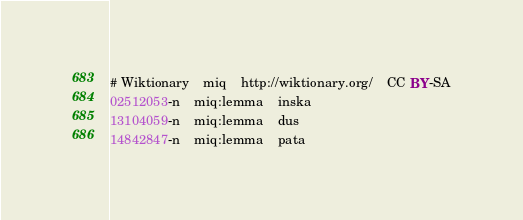Convert code to text. <code><loc_0><loc_0><loc_500><loc_500><_SQL_># Wiktionary	miq	http://wiktionary.org/	CC BY-SA
02512053-n	miq:lemma	inska
13104059-n	miq:lemma	dus
14842847-n	miq:lemma	pata
</code> 